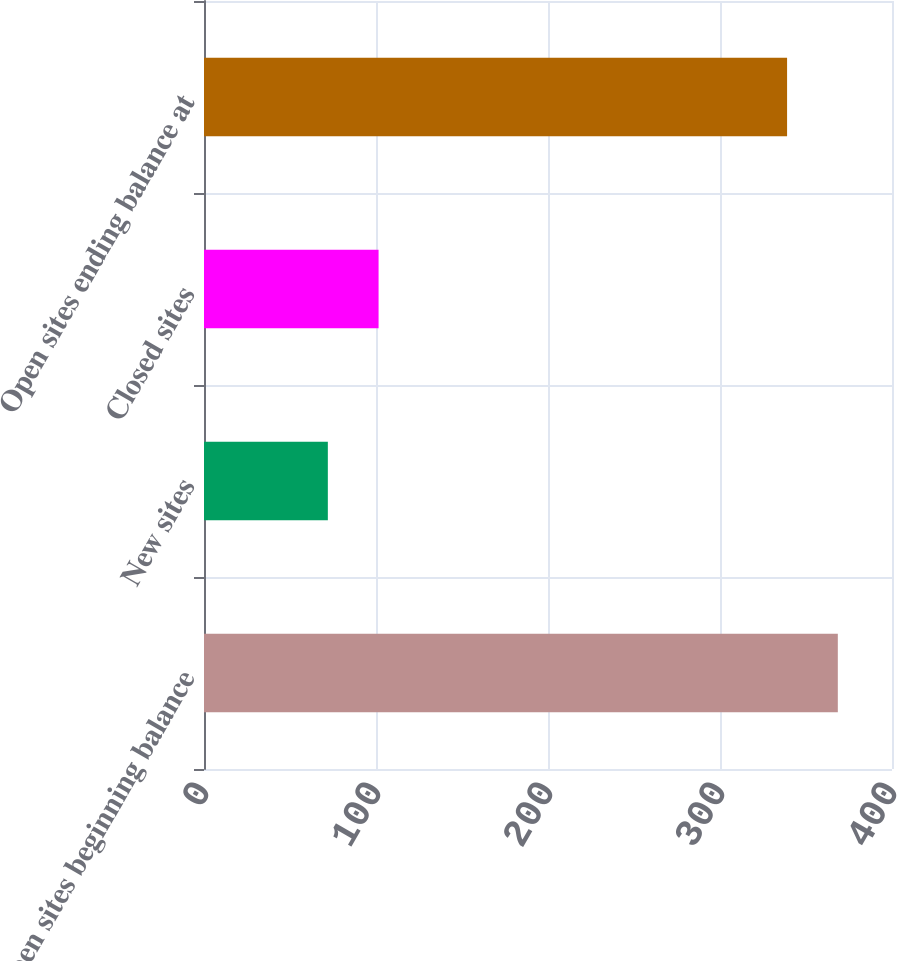<chart> <loc_0><loc_0><loc_500><loc_500><bar_chart><fcel>Open sites beginning balance<fcel>New sites<fcel>Closed sites<fcel>Open sites ending balance at<nl><fcel>368.5<fcel>72<fcel>101.5<fcel>339<nl></chart> 